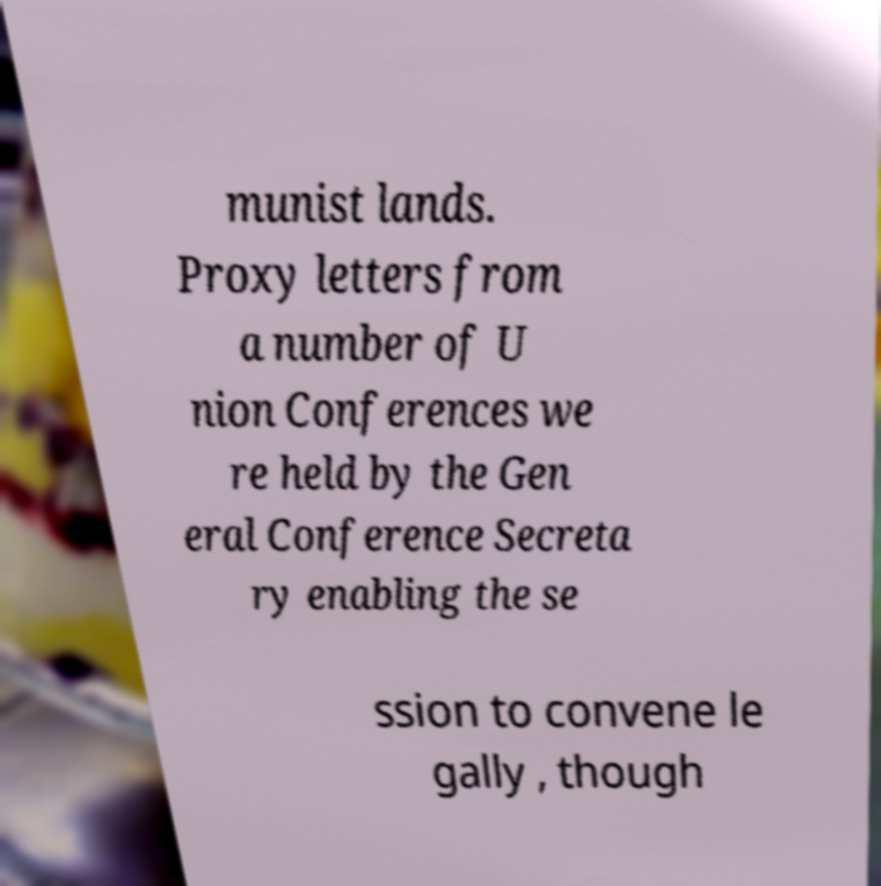Please identify and transcribe the text found in this image. munist lands. Proxy letters from a number of U nion Conferences we re held by the Gen eral Conference Secreta ry enabling the se ssion to convene le gally , though 